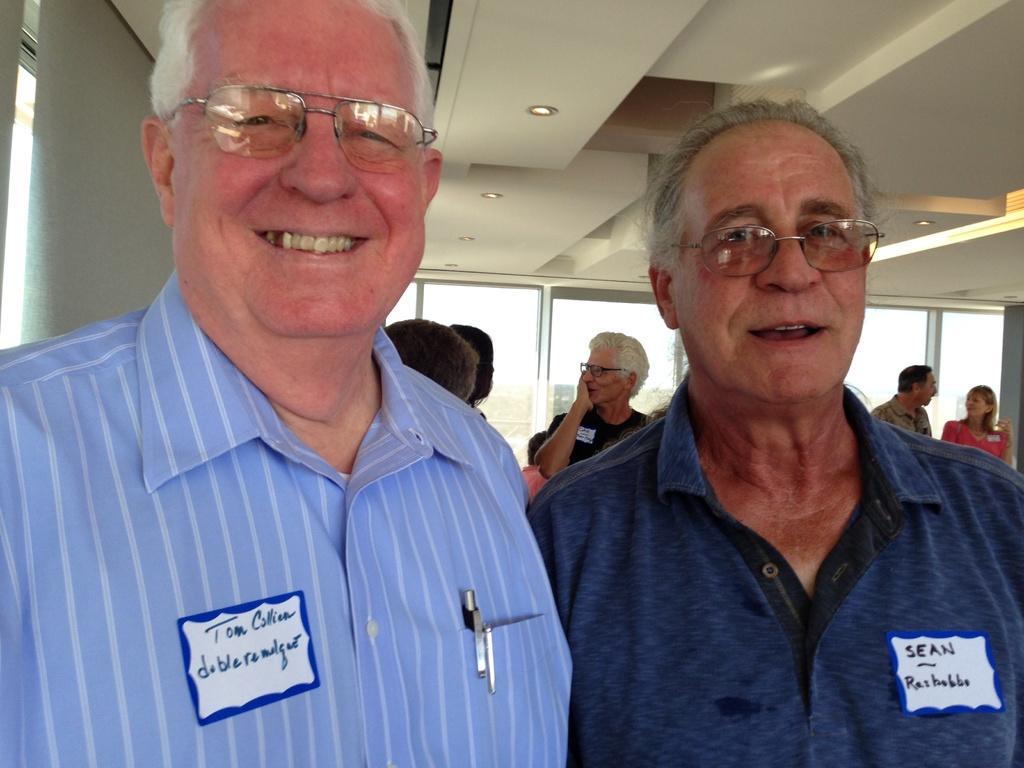Describe this image in one or two sentences. This image is clicked inside a room. There are some persons in the image. There are two persons in the front. They are men. They are laughing. 